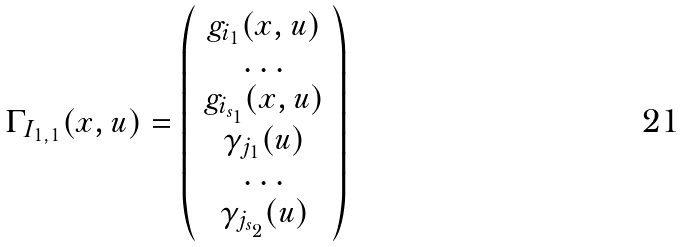<formula> <loc_0><loc_0><loc_500><loc_500>\Gamma _ { I _ { 1 , 1 } } ( x , u ) = \left ( \begin{array} { c } g _ { i _ { 1 } } ( x , u ) \\ \dots \\ g _ { i _ { s _ { 1 } } } ( x , u ) \\ \gamma _ { j _ { 1 } } ( u ) \\ \dots \\ \gamma _ { j _ { s _ { 2 } } } ( u ) \end{array} \right )</formula> 